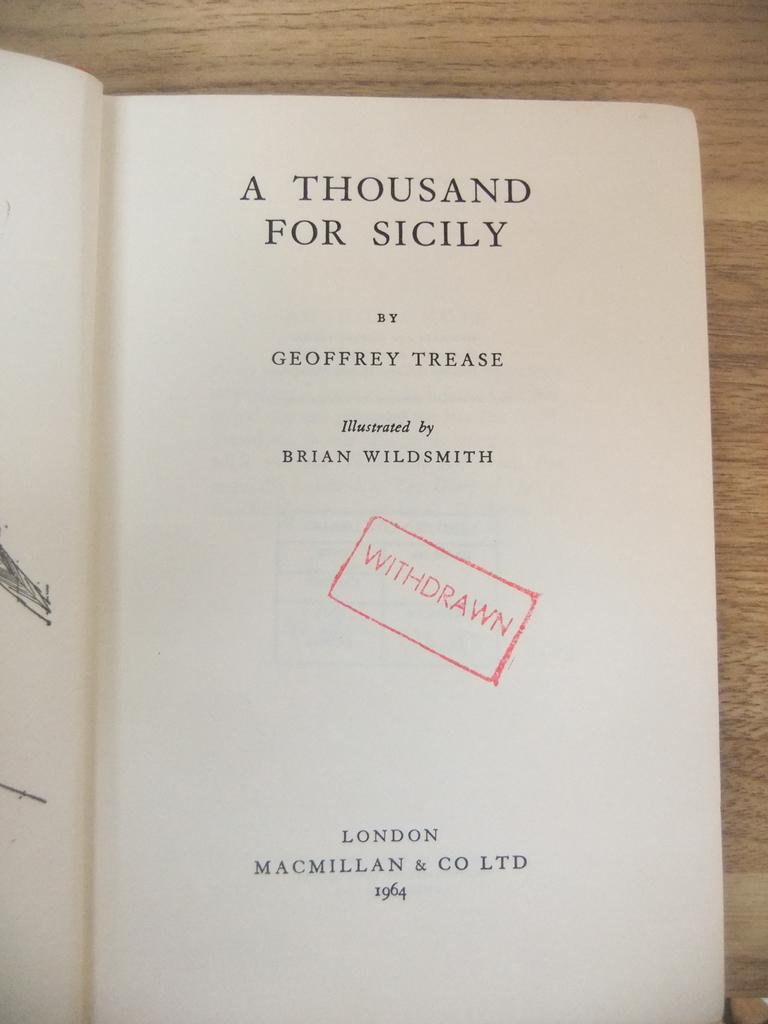<image>
Describe the image concisely. a white journal for A Thousand for Sicily 